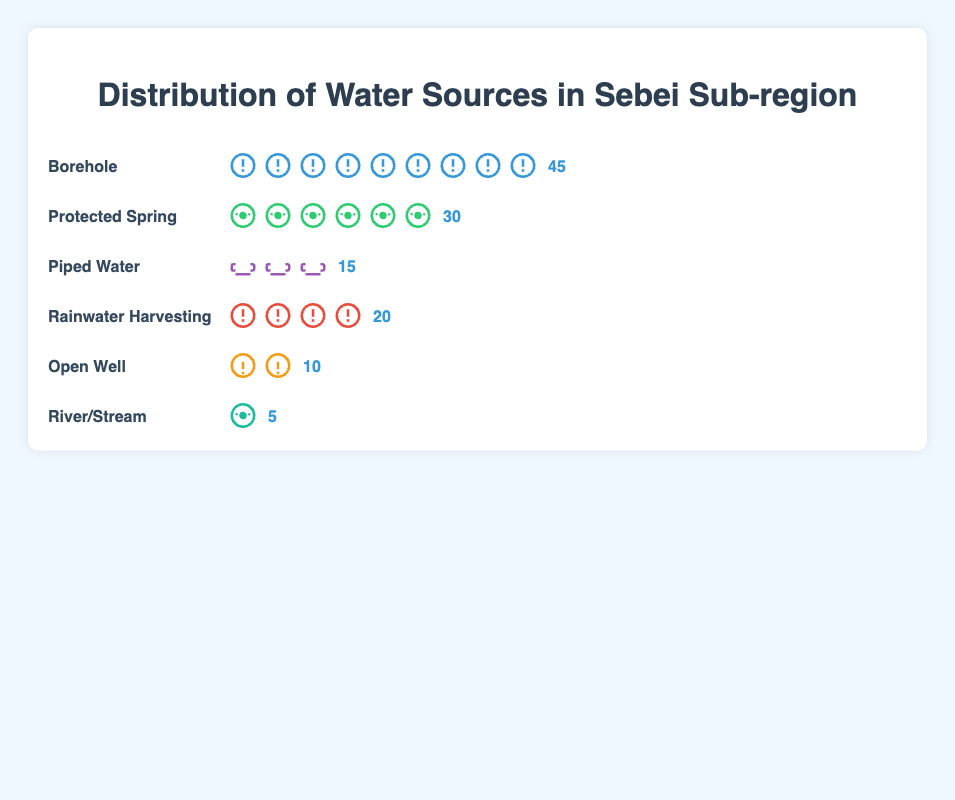Which water source is most commonly used by Sebei residents? The figure shows the distribution of water sources, with icons representing each type of source. The Borehole has the most icons, each representing a usage count.
Answer: Borehole How many residents use protected springs and open wells combined? To find the combined usage, add the number of residents using Protected Spring (30) and Open Well (10). Thus, the sum is 30 + 10.
Answer: 40 Which water source has the least usage? The figure has different water sources with varying counts. The River/Stream source has the fewest icons (5), making it the least used.
Answer: River/Stream What is the total number of residents using either boreholes or rainwater harvesting? Add the counts for Borehole (45) and Rainwater Harvesting (20) to find the total: 45 + 20.
Answer: 65 How does the usage of piped water compare to that of protected springs? Compare the counts: Piped Water (15) and Protected Spring (30). Notice that the count for Protected Spring is higher.
Answer: Protected Spring has twice (2 times) as much usage compared to Piped Water Are there more residents using Rainwater Harvesting or Open Well? Compare the counts: Rainwater Harvesting (20) and Open Well (10). Rainwater Harvesting has a higher count.
Answer: Rainwater Harvesting Which two water sources have an equal number of residents using them as Rainwater Harvesting alone? Rainwater Harvesting has 20 residents. Adding the counts of River/Stream (5) and Open Well (10) results in 15. This sum is less than 20, so the Protected Spring (30) is the closest count to Rainwater Harvesting (20). No two sources individually sum up to 20. Check back and verify Rainwater Harvesting (20) itself matches Rainwater Harvesting.
Answer: No two sources combined equal Rainwater Harvesting usage alone What proportion of the total water sources does Borehole usage represent? Sum all counts: 45 (Borehole) + 30 (Protected Spring) + 15 (Piped Water) + 20 (Rainwater Harvesting) + 10 (Open Well) + 5 (River/Stream) = 125. The proportion for Borehole is 45/125. To convert to percentage: (45/125) * 100 = 36%.
Answer: 36% How many more residents use Boreholes than River/Streams? Subtract the counts: 45 (Borehole) - 5 (River/Stream).
Answer: 40 What's the average number of residents per water source type? Sum all counts: 45 (Borehole) + 30 (Protected Spring) + 15 (Piped Water) + 20 (Rainwater Harvesting) + 10 (Open Well) + 5 (River/Stream) = 125. With six water sources, the average is 125/6.
Answer: Approximately 20.8 